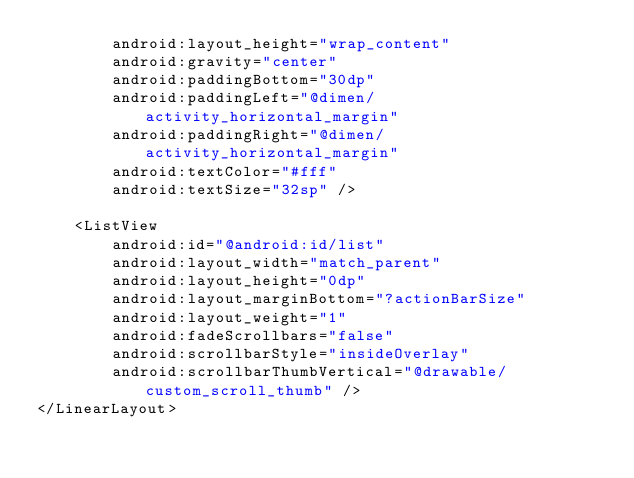<code> <loc_0><loc_0><loc_500><loc_500><_XML_>        android:layout_height="wrap_content"
        android:gravity="center"
        android:paddingBottom="30dp"
        android:paddingLeft="@dimen/activity_horizontal_margin"
        android:paddingRight="@dimen/activity_horizontal_margin"
        android:textColor="#fff"
        android:textSize="32sp" />

    <ListView
        android:id="@android:id/list"
        android:layout_width="match_parent"
        android:layout_height="0dp"
        android:layout_marginBottom="?actionBarSize"
        android:layout_weight="1"
        android:fadeScrollbars="false"
        android:scrollbarStyle="insideOverlay"
        android:scrollbarThumbVertical="@drawable/custom_scroll_thumb" />
</LinearLayout></code> 